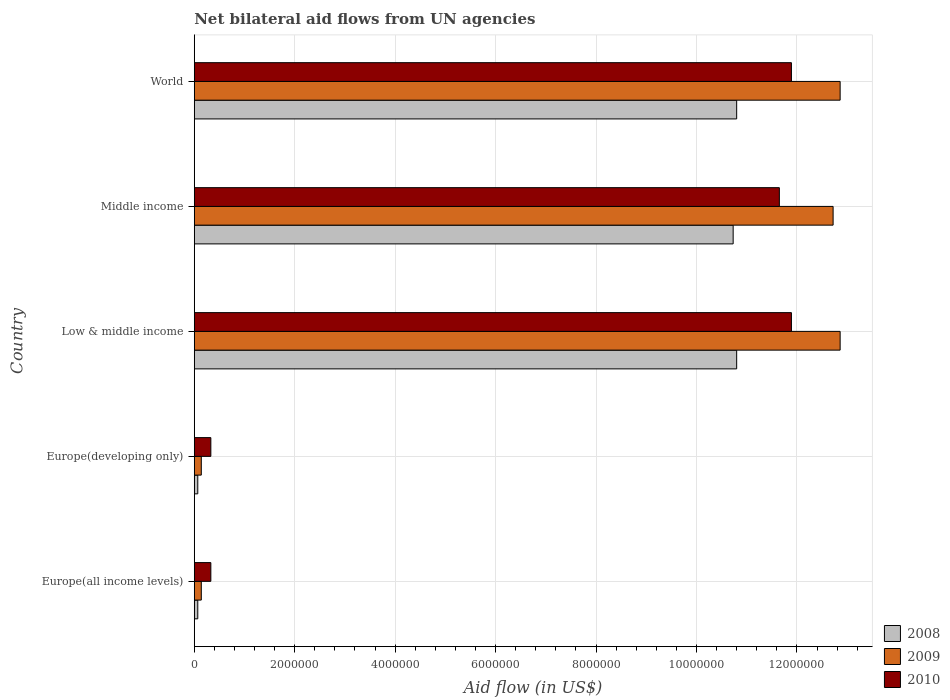How many different coloured bars are there?
Ensure brevity in your answer.  3. How many groups of bars are there?
Ensure brevity in your answer.  5. Are the number of bars per tick equal to the number of legend labels?
Give a very brief answer. Yes. How many bars are there on the 1st tick from the bottom?
Your answer should be very brief. 3. What is the label of the 4th group of bars from the top?
Make the answer very short. Europe(developing only). Across all countries, what is the maximum net bilateral aid flow in 2009?
Provide a succinct answer. 1.29e+07. Across all countries, what is the minimum net bilateral aid flow in 2008?
Your answer should be very brief. 7.00e+04. In which country was the net bilateral aid flow in 2008 minimum?
Offer a very short reply. Europe(all income levels). What is the total net bilateral aid flow in 2009 in the graph?
Your answer should be very brief. 3.87e+07. What is the difference between the net bilateral aid flow in 2009 in Europe(developing only) and the net bilateral aid flow in 2008 in World?
Give a very brief answer. -1.07e+07. What is the average net bilateral aid flow in 2008 per country?
Your answer should be very brief. 6.49e+06. What is the difference between the net bilateral aid flow in 2009 and net bilateral aid flow in 2010 in Middle income?
Give a very brief answer. 1.07e+06. In how many countries, is the net bilateral aid flow in 2008 greater than 11200000 US$?
Keep it short and to the point. 0. What is the ratio of the net bilateral aid flow in 2008 in Low & middle income to that in Middle income?
Offer a very short reply. 1.01. Is the net bilateral aid flow in 2010 in Europe(developing only) less than that in World?
Keep it short and to the point. Yes. Is the difference between the net bilateral aid flow in 2009 in Europe(developing only) and Middle income greater than the difference between the net bilateral aid flow in 2010 in Europe(developing only) and Middle income?
Provide a short and direct response. No. What is the difference between the highest and the lowest net bilateral aid flow in 2008?
Ensure brevity in your answer.  1.07e+07. What does the 2nd bar from the top in Middle income represents?
Give a very brief answer. 2009. Is it the case that in every country, the sum of the net bilateral aid flow in 2008 and net bilateral aid flow in 2009 is greater than the net bilateral aid flow in 2010?
Your response must be concise. No. Are all the bars in the graph horizontal?
Offer a very short reply. Yes. How many countries are there in the graph?
Ensure brevity in your answer.  5. How many legend labels are there?
Your answer should be very brief. 3. How are the legend labels stacked?
Give a very brief answer. Vertical. What is the title of the graph?
Ensure brevity in your answer.  Net bilateral aid flows from UN agencies. Does "1962" appear as one of the legend labels in the graph?
Your response must be concise. No. What is the label or title of the X-axis?
Your response must be concise. Aid flow (in US$). What is the Aid flow (in US$) in 2008 in Low & middle income?
Keep it short and to the point. 1.08e+07. What is the Aid flow (in US$) in 2009 in Low & middle income?
Ensure brevity in your answer.  1.29e+07. What is the Aid flow (in US$) in 2010 in Low & middle income?
Your answer should be compact. 1.19e+07. What is the Aid flow (in US$) of 2008 in Middle income?
Give a very brief answer. 1.07e+07. What is the Aid flow (in US$) of 2009 in Middle income?
Offer a very short reply. 1.27e+07. What is the Aid flow (in US$) of 2010 in Middle income?
Your response must be concise. 1.16e+07. What is the Aid flow (in US$) in 2008 in World?
Keep it short and to the point. 1.08e+07. What is the Aid flow (in US$) of 2009 in World?
Your response must be concise. 1.29e+07. What is the Aid flow (in US$) of 2010 in World?
Ensure brevity in your answer.  1.19e+07. Across all countries, what is the maximum Aid flow (in US$) in 2008?
Make the answer very short. 1.08e+07. Across all countries, what is the maximum Aid flow (in US$) in 2009?
Give a very brief answer. 1.29e+07. Across all countries, what is the maximum Aid flow (in US$) of 2010?
Your response must be concise. 1.19e+07. Across all countries, what is the minimum Aid flow (in US$) of 2008?
Provide a succinct answer. 7.00e+04. Across all countries, what is the minimum Aid flow (in US$) of 2010?
Ensure brevity in your answer.  3.30e+05. What is the total Aid flow (in US$) in 2008 in the graph?
Provide a succinct answer. 3.25e+07. What is the total Aid flow (in US$) in 2009 in the graph?
Provide a short and direct response. 3.87e+07. What is the total Aid flow (in US$) of 2010 in the graph?
Give a very brief answer. 3.61e+07. What is the difference between the Aid flow (in US$) in 2008 in Europe(all income levels) and that in Europe(developing only)?
Ensure brevity in your answer.  0. What is the difference between the Aid flow (in US$) in 2009 in Europe(all income levels) and that in Europe(developing only)?
Ensure brevity in your answer.  0. What is the difference between the Aid flow (in US$) in 2010 in Europe(all income levels) and that in Europe(developing only)?
Keep it short and to the point. 0. What is the difference between the Aid flow (in US$) of 2008 in Europe(all income levels) and that in Low & middle income?
Ensure brevity in your answer.  -1.07e+07. What is the difference between the Aid flow (in US$) in 2009 in Europe(all income levels) and that in Low & middle income?
Offer a terse response. -1.27e+07. What is the difference between the Aid flow (in US$) in 2010 in Europe(all income levels) and that in Low & middle income?
Give a very brief answer. -1.16e+07. What is the difference between the Aid flow (in US$) in 2008 in Europe(all income levels) and that in Middle income?
Ensure brevity in your answer.  -1.07e+07. What is the difference between the Aid flow (in US$) of 2009 in Europe(all income levels) and that in Middle income?
Offer a very short reply. -1.26e+07. What is the difference between the Aid flow (in US$) of 2010 in Europe(all income levels) and that in Middle income?
Give a very brief answer. -1.13e+07. What is the difference between the Aid flow (in US$) in 2008 in Europe(all income levels) and that in World?
Give a very brief answer. -1.07e+07. What is the difference between the Aid flow (in US$) of 2009 in Europe(all income levels) and that in World?
Offer a very short reply. -1.27e+07. What is the difference between the Aid flow (in US$) in 2010 in Europe(all income levels) and that in World?
Your response must be concise. -1.16e+07. What is the difference between the Aid flow (in US$) in 2008 in Europe(developing only) and that in Low & middle income?
Ensure brevity in your answer.  -1.07e+07. What is the difference between the Aid flow (in US$) of 2009 in Europe(developing only) and that in Low & middle income?
Make the answer very short. -1.27e+07. What is the difference between the Aid flow (in US$) in 2010 in Europe(developing only) and that in Low & middle income?
Keep it short and to the point. -1.16e+07. What is the difference between the Aid flow (in US$) in 2008 in Europe(developing only) and that in Middle income?
Keep it short and to the point. -1.07e+07. What is the difference between the Aid flow (in US$) in 2009 in Europe(developing only) and that in Middle income?
Ensure brevity in your answer.  -1.26e+07. What is the difference between the Aid flow (in US$) in 2010 in Europe(developing only) and that in Middle income?
Ensure brevity in your answer.  -1.13e+07. What is the difference between the Aid flow (in US$) of 2008 in Europe(developing only) and that in World?
Provide a short and direct response. -1.07e+07. What is the difference between the Aid flow (in US$) of 2009 in Europe(developing only) and that in World?
Offer a very short reply. -1.27e+07. What is the difference between the Aid flow (in US$) in 2010 in Europe(developing only) and that in World?
Your answer should be compact. -1.16e+07. What is the difference between the Aid flow (in US$) in 2010 in Low & middle income and that in Middle income?
Provide a short and direct response. 2.40e+05. What is the difference between the Aid flow (in US$) of 2008 in Low & middle income and that in World?
Your answer should be compact. 0. What is the difference between the Aid flow (in US$) in 2009 in Low & middle income and that in World?
Your response must be concise. 0. What is the difference between the Aid flow (in US$) of 2008 in Middle income and that in World?
Your answer should be compact. -7.00e+04. What is the difference between the Aid flow (in US$) in 2009 in Middle income and that in World?
Your answer should be compact. -1.40e+05. What is the difference between the Aid flow (in US$) in 2008 in Europe(all income levels) and the Aid flow (in US$) in 2010 in Europe(developing only)?
Offer a very short reply. -2.60e+05. What is the difference between the Aid flow (in US$) of 2008 in Europe(all income levels) and the Aid flow (in US$) of 2009 in Low & middle income?
Your answer should be very brief. -1.28e+07. What is the difference between the Aid flow (in US$) in 2008 in Europe(all income levels) and the Aid flow (in US$) in 2010 in Low & middle income?
Give a very brief answer. -1.18e+07. What is the difference between the Aid flow (in US$) of 2009 in Europe(all income levels) and the Aid flow (in US$) of 2010 in Low & middle income?
Your response must be concise. -1.18e+07. What is the difference between the Aid flow (in US$) in 2008 in Europe(all income levels) and the Aid flow (in US$) in 2009 in Middle income?
Make the answer very short. -1.26e+07. What is the difference between the Aid flow (in US$) of 2008 in Europe(all income levels) and the Aid flow (in US$) of 2010 in Middle income?
Your answer should be very brief. -1.16e+07. What is the difference between the Aid flow (in US$) of 2009 in Europe(all income levels) and the Aid flow (in US$) of 2010 in Middle income?
Provide a succinct answer. -1.15e+07. What is the difference between the Aid flow (in US$) of 2008 in Europe(all income levels) and the Aid flow (in US$) of 2009 in World?
Give a very brief answer. -1.28e+07. What is the difference between the Aid flow (in US$) in 2008 in Europe(all income levels) and the Aid flow (in US$) in 2010 in World?
Your answer should be very brief. -1.18e+07. What is the difference between the Aid flow (in US$) in 2009 in Europe(all income levels) and the Aid flow (in US$) in 2010 in World?
Your answer should be compact. -1.18e+07. What is the difference between the Aid flow (in US$) in 2008 in Europe(developing only) and the Aid flow (in US$) in 2009 in Low & middle income?
Make the answer very short. -1.28e+07. What is the difference between the Aid flow (in US$) in 2008 in Europe(developing only) and the Aid flow (in US$) in 2010 in Low & middle income?
Your answer should be very brief. -1.18e+07. What is the difference between the Aid flow (in US$) of 2009 in Europe(developing only) and the Aid flow (in US$) of 2010 in Low & middle income?
Ensure brevity in your answer.  -1.18e+07. What is the difference between the Aid flow (in US$) of 2008 in Europe(developing only) and the Aid flow (in US$) of 2009 in Middle income?
Your answer should be very brief. -1.26e+07. What is the difference between the Aid flow (in US$) in 2008 in Europe(developing only) and the Aid flow (in US$) in 2010 in Middle income?
Offer a terse response. -1.16e+07. What is the difference between the Aid flow (in US$) of 2009 in Europe(developing only) and the Aid flow (in US$) of 2010 in Middle income?
Your response must be concise. -1.15e+07. What is the difference between the Aid flow (in US$) of 2008 in Europe(developing only) and the Aid flow (in US$) of 2009 in World?
Offer a very short reply. -1.28e+07. What is the difference between the Aid flow (in US$) in 2008 in Europe(developing only) and the Aid flow (in US$) in 2010 in World?
Your answer should be compact. -1.18e+07. What is the difference between the Aid flow (in US$) of 2009 in Europe(developing only) and the Aid flow (in US$) of 2010 in World?
Provide a succinct answer. -1.18e+07. What is the difference between the Aid flow (in US$) in 2008 in Low & middle income and the Aid flow (in US$) in 2009 in Middle income?
Provide a succinct answer. -1.92e+06. What is the difference between the Aid flow (in US$) in 2008 in Low & middle income and the Aid flow (in US$) in 2010 in Middle income?
Offer a very short reply. -8.50e+05. What is the difference between the Aid flow (in US$) of 2009 in Low & middle income and the Aid flow (in US$) of 2010 in Middle income?
Give a very brief answer. 1.21e+06. What is the difference between the Aid flow (in US$) in 2008 in Low & middle income and the Aid flow (in US$) in 2009 in World?
Keep it short and to the point. -2.06e+06. What is the difference between the Aid flow (in US$) of 2008 in Low & middle income and the Aid flow (in US$) of 2010 in World?
Provide a short and direct response. -1.09e+06. What is the difference between the Aid flow (in US$) of 2009 in Low & middle income and the Aid flow (in US$) of 2010 in World?
Your answer should be compact. 9.70e+05. What is the difference between the Aid flow (in US$) of 2008 in Middle income and the Aid flow (in US$) of 2009 in World?
Your answer should be compact. -2.13e+06. What is the difference between the Aid flow (in US$) in 2008 in Middle income and the Aid flow (in US$) in 2010 in World?
Offer a terse response. -1.16e+06. What is the difference between the Aid flow (in US$) of 2009 in Middle income and the Aid flow (in US$) of 2010 in World?
Keep it short and to the point. 8.30e+05. What is the average Aid flow (in US$) of 2008 per country?
Provide a succinct answer. 6.49e+06. What is the average Aid flow (in US$) of 2009 per country?
Your response must be concise. 7.74e+06. What is the average Aid flow (in US$) of 2010 per country?
Provide a succinct answer. 7.22e+06. What is the difference between the Aid flow (in US$) in 2009 and Aid flow (in US$) in 2010 in Europe(all income levels)?
Give a very brief answer. -1.90e+05. What is the difference between the Aid flow (in US$) of 2008 and Aid flow (in US$) of 2009 in Europe(developing only)?
Provide a succinct answer. -7.00e+04. What is the difference between the Aid flow (in US$) of 2008 and Aid flow (in US$) of 2010 in Europe(developing only)?
Your answer should be compact. -2.60e+05. What is the difference between the Aid flow (in US$) of 2008 and Aid flow (in US$) of 2009 in Low & middle income?
Your answer should be very brief. -2.06e+06. What is the difference between the Aid flow (in US$) in 2008 and Aid flow (in US$) in 2010 in Low & middle income?
Offer a very short reply. -1.09e+06. What is the difference between the Aid flow (in US$) of 2009 and Aid flow (in US$) of 2010 in Low & middle income?
Offer a terse response. 9.70e+05. What is the difference between the Aid flow (in US$) of 2008 and Aid flow (in US$) of 2009 in Middle income?
Offer a terse response. -1.99e+06. What is the difference between the Aid flow (in US$) of 2008 and Aid flow (in US$) of 2010 in Middle income?
Offer a very short reply. -9.20e+05. What is the difference between the Aid flow (in US$) of 2009 and Aid flow (in US$) of 2010 in Middle income?
Ensure brevity in your answer.  1.07e+06. What is the difference between the Aid flow (in US$) of 2008 and Aid flow (in US$) of 2009 in World?
Your answer should be very brief. -2.06e+06. What is the difference between the Aid flow (in US$) of 2008 and Aid flow (in US$) of 2010 in World?
Make the answer very short. -1.09e+06. What is the difference between the Aid flow (in US$) of 2009 and Aid flow (in US$) of 2010 in World?
Keep it short and to the point. 9.70e+05. What is the ratio of the Aid flow (in US$) of 2009 in Europe(all income levels) to that in Europe(developing only)?
Make the answer very short. 1. What is the ratio of the Aid flow (in US$) of 2010 in Europe(all income levels) to that in Europe(developing only)?
Offer a terse response. 1. What is the ratio of the Aid flow (in US$) of 2008 in Europe(all income levels) to that in Low & middle income?
Make the answer very short. 0.01. What is the ratio of the Aid flow (in US$) in 2009 in Europe(all income levels) to that in Low & middle income?
Provide a succinct answer. 0.01. What is the ratio of the Aid flow (in US$) in 2010 in Europe(all income levels) to that in Low & middle income?
Ensure brevity in your answer.  0.03. What is the ratio of the Aid flow (in US$) in 2008 in Europe(all income levels) to that in Middle income?
Offer a very short reply. 0.01. What is the ratio of the Aid flow (in US$) of 2009 in Europe(all income levels) to that in Middle income?
Provide a short and direct response. 0.01. What is the ratio of the Aid flow (in US$) in 2010 in Europe(all income levels) to that in Middle income?
Make the answer very short. 0.03. What is the ratio of the Aid flow (in US$) in 2008 in Europe(all income levels) to that in World?
Your answer should be compact. 0.01. What is the ratio of the Aid flow (in US$) in 2009 in Europe(all income levels) to that in World?
Your answer should be very brief. 0.01. What is the ratio of the Aid flow (in US$) in 2010 in Europe(all income levels) to that in World?
Ensure brevity in your answer.  0.03. What is the ratio of the Aid flow (in US$) in 2008 in Europe(developing only) to that in Low & middle income?
Ensure brevity in your answer.  0.01. What is the ratio of the Aid flow (in US$) of 2009 in Europe(developing only) to that in Low & middle income?
Offer a terse response. 0.01. What is the ratio of the Aid flow (in US$) of 2010 in Europe(developing only) to that in Low & middle income?
Provide a succinct answer. 0.03. What is the ratio of the Aid flow (in US$) of 2008 in Europe(developing only) to that in Middle income?
Keep it short and to the point. 0.01. What is the ratio of the Aid flow (in US$) in 2009 in Europe(developing only) to that in Middle income?
Your response must be concise. 0.01. What is the ratio of the Aid flow (in US$) in 2010 in Europe(developing only) to that in Middle income?
Your answer should be very brief. 0.03. What is the ratio of the Aid flow (in US$) of 2008 in Europe(developing only) to that in World?
Offer a very short reply. 0.01. What is the ratio of the Aid flow (in US$) in 2009 in Europe(developing only) to that in World?
Offer a terse response. 0.01. What is the ratio of the Aid flow (in US$) in 2010 in Europe(developing only) to that in World?
Make the answer very short. 0.03. What is the ratio of the Aid flow (in US$) of 2008 in Low & middle income to that in Middle income?
Provide a succinct answer. 1.01. What is the ratio of the Aid flow (in US$) of 2009 in Low & middle income to that in Middle income?
Ensure brevity in your answer.  1.01. What is the ratio of the Aid flow (in US$) of 2010 in Low & middle income to that in Middle income?
Offer a very short reply. 1.02. What is the ratio of the Aid flow (in US$) in 2009 in Low & middle income to that in World?
Ensure brevity in your answer.  1. What is the ratio of the Aid flow (in US$) of 2010 in Low & middle income to that in World?
Provide a succinct answer. 1. What is the ratio of the Aid flow (in US$) of 2010 in Middle income to that in World?
Your response must be concise. 0.98. What is the difference between the highest and the lowest Aid flow (in US$) of 2008?
Provide a succinct answer. 1.07e+07. What is the difference between the highest and the lowest Aid flow (in US$) in 2009?
Make the answer very short. 1.27e+07. What is the difference between the highest and the lowest Aid flow (in US$) of 2010?
Ensure brevity in your answer.  1.16e+07. 